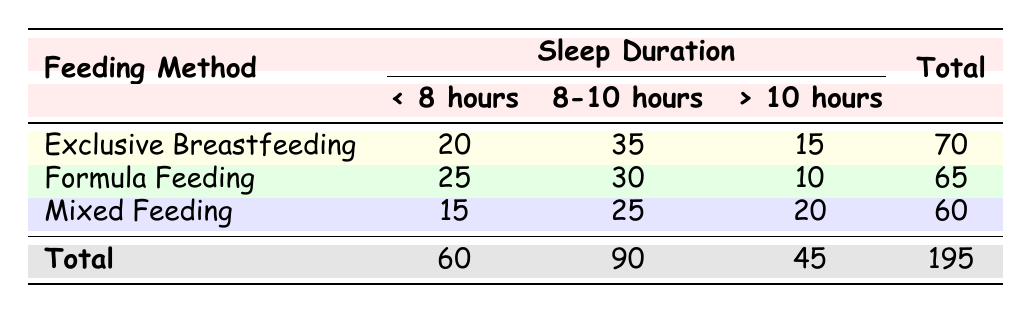What is the total count of infants who sleep less than 8 hours? By looking at the "< 8 hours" column, we can find the counts for each feeding method: Exclusive Breastfeeding has 20, Formula Feeding has 25, and Mixed Feeding has 15. Adding these together gives: 20 + 25 + 15 = 60.
Answer: 60 Which feeding method has the highest count of infants sleeping 8-10 hours? In the "8-10 hours" column, we see the counts: Exclusive Breastfeeding has 35, Formula Feeding has 30, and Mixed Feeding has 25. The highest count is 35 from Exclusive Breastfeeding.
Answer: Exclusive Breastfeeding What percentage of infants in Mixed Feeding sleep more than 10 hours? The count of infants in Mixed Feeding who sleep more than 10 hours is 20. The total count for Mixed Feeding is 60. To find the percentage: (20 / 60) * 100 = 33.33%.
Answer: 33.33% Is it true that more infants sleep less than 8 hours with Formula Feeding than with Exclusive Breastfeeding? The counts for "< 8 hours" are 25 for Formula Feeding and 20 for Exclusive Breastfeeding. Since 25 is greater than 20, the statement is true.
Answer: Yes What is the average sleep duration count for infants across all feeding methods? We need the total counts for all sleep durations: Less than 8 hours (60), 8-10 hours (90), and more than 10 hours (45). Summing these gives a total of 60 + 90 + 45 = 195. To find the average, divide by the number of categories (3): 195 / 3 = 65.
Answer: 65 What is the difference in count of infants sleeping more than 10 hours between Exclusive Breastfeeding and Formula Feeding? For Exclusive Breastfeeding, the count is 15, and for Formula Feeding, it is 10. Subtracting these gives: 15 - 10 = 5.
Answer: 5 How many infants sleep more than 10 hours in total? To find the total sleeping more than 10 hours, we add the counts from all feeding methods: Exclusive Breastfeeding has 15, Formula Feeding has 10, and Mixed Feeding has 20. Summing these gives: 15 + 10 + 20 = 45.
Answer: 45 Which feeding method has the lowest total sleep duration count? The total counts are Exclusive Breastfeeding 70, Formula Feeding 65, and Mixed Feeding 60. The lowest total is from Mixed Feeding with 60.
Answer: Mixed Feeding 